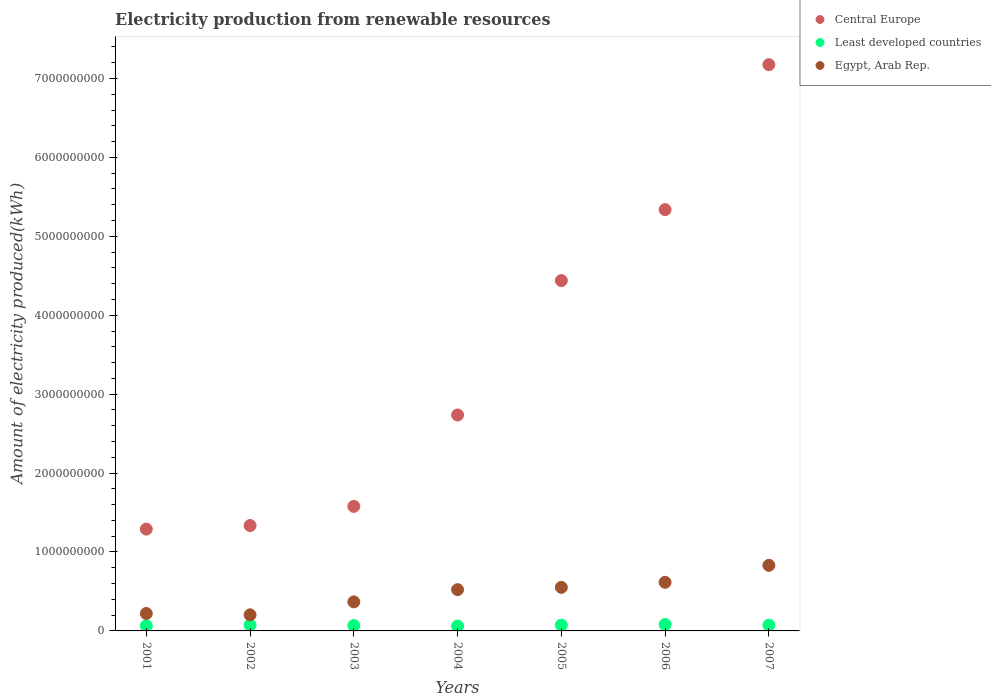Is the number of dotlines equal to the number of legend labels?
Keep it short and to the point. Yes. What is the amount of electricity produced in Egypt, Arab Rep. in 2002?
Offer a very short reply. 2.04e+08. Across all years, what is the maximum amount of electricity produced in Egypt, Arab Rep.?
Ensure brevity in your answer.  8.31e+08. Across all years, what is the minimum amount of electricity produced in Egypt, Arab Rep.?
Provide a succinct answer. 2.04e+08. In which year was the amount of electricity produced in Central Europe maximum?
Your answer should be compact. 2007. In which year was the amount of electricity produced in Central Europe minimum?
Offer a very short reply. 2001. What is the total amount of electricity produced in Least developed countries in the graph?
Keep it short and to the point. 4.96e+08. What is the difference between the amount of electricity produced in Egypt, Arab Rep. in 2001 and that in 2007?
Keep it short and to the point. -6.10e+08. What is the difference between the amount of electricity produced in Central Europe in 2006 and the amount of electricity produced in Egypt, Arab Rep. in 2002?
Your answer should be compact. 5.13e+09. What is the average amount of electricity produced in Least developed countries per year?
Provide a succinct answer. 7.09e+07. In the year 2004, what is the difference between the amount of electricity produced in Egypt, Arab Rep. and amount of electricity produced in Least developed countries?
Provide a succinct answer. 4.61e+08. What is the ratio of the amount of electricity produced in Central Europe in 2004 to that in 2005?
Provide a short and direct response. 0.62. Is the difference between the amount of electricity produced in Egypt, Arab Rep. in 2003 and 2005 greater than the difference between the amount of electricity produced in Least developed countries in 2003 and 2005?
Provide a short and direct response. No. What is the difference between the highest and the second highest amount of electricity produced in Egypt, Arab Rep.?
Give a very brief answer. 2.15e+08. What is the difference between the highest and the lowest amount of electricity produced in Central Europe?
Your answer should be compact. 5.88e+09. In how many years, is the amount of electricity produced in Egypt, Arab Rep. greater than the average amount of electricity produced in Egypt, Arab Rep. taken over all years?
Provide a succinct answer. 4. Does the amount of electricity produced in Central Europe monotonically increase over the years?
Provide a short and direct response. Yes. How many dotlines are there?
Offer a very short reply. 3. How many years are there in the graph?
Offer a very short reply. 7. What is the difference between two consecutive major ticks on the Y-axis?
Offer a very short reply. 1.00e+09. Does the graph contain any zero values?
Make the answer very short. No. How many legend labels are there?
Your answer should be very brief. 3. How are the legend labels stacked?
Offer a terse response. Vertical. What is the title of the graph?
Your answer should be very brief. Electricity production from renewable resources. Does "Saudi Arabia" appear as one of the legend labels in the graph?
Offer a terse response. No. What is the label or title of the Y-axis?
Offer a very short reply. Amount of electricity produced(kWh). What is the Amount of electricity produced(kWh) in Central Europe in 2001?
Your answer should be compact. 1.29e+09. What is the Amount of electricity produced(kWh) in Least developed countries in 2001?
Provide a short and direct response. 6.60e+07. What is the Amount of electricity produced(kWh) of Egypt, Arab Rep. in 2001?
Give a very brief answer. 2.21e+08. What is the Amount of electricity produced(kWh) of Central Europe in 2002?
Offer a terse response. 1.34e+09. What is the Amount of electricity produced(kWh) in Least developed countries in 2002?
Offer a terse response. 7.30e+07. What is the Amount of electricity produced(kWh) of Egypt, Arab Rep. in 2002?
Offer a very short reply. 2.04e+08. What is the Amount of electricity produced(kWh) in Central Europe in 2003?
Make the answer very short. 1.58e+09. What is the Amount of electricity produced(kWh) of Least developed countries in 2003?
Ensure brevity in your answer.  6.80e+07. What is the Amount of electricity produced(kWh) in Egypt, Arab Rep. in 2003?
Offer a very short reply. 3.68e+08. What is the Amount of electricity produced(kWh) in Central Europe in 2004?
Provide a short and direct response. 2.74e+09. What is the Amount of electricity produced(kWh) of Least developed countries in 2004?
Give a very brief answer. 6.20e+07. What is the Amount of electricity produced(kWh) of Egypt, Arab Rep. in 2004?
Keep it short and to the point. 5.23e+08. What is the Amount of electricity produced(kWh) in Central Europe in 2005?
Offer a terse response. 4.44e+09. What is the Amount of electricity produced(kWh) in Least developed countries in 2005?
Your answer should be compact. 7.30e+07. What is the Amount of electricity produced(kWh) of Egypt, Arab Rep. in 2005?
Offer a terse response. 5.52e+08. What is the Amount of electricity produced(kWh) in Central Europe in 2006?
Keep it short and to the point. 5.34e+09. What is the Amount of electricity produced(kWh) in Least developed countries in 2006?
Provide a short and direct response. 8.10e+07. What is the Amount of electricity produced(kWh) in Egypt, Arab Rep. in 2006?
Offer a very short reply. 6.16e+08. What is the Amount of electricity produced(kWh) in Central Europe in 2007?
Provide a succinct answer. 7.18e+09. What is the Amount of electricity produced(kWh) in Least developed countries in 2007?
Your answer should be compact. 7.30e+07. What is the Amount of electricity produced(kWh) of Egypt, Arab Rep. in 2007?
Provide a short and direct response. 8.31e+08. Across all years, what is the maximum Amount of electricity produced(kWh) of Central Europe?
Provide a short and direct response. 7.18e+09. Across all years, what is the maximum Amount of electricity produced(kWh) of Least developed countries?
Provide a succinct answer. 8.10e+07. Across all years, what is the maximum Amount of electricity produced(kWh) of Egypt, Arab Rep.?
Your answer should be compact. 8.31e+08. Across all years, what is the minimum Amount of electricity produced(kWh) in Central Europe?
Offer a very short reply. 1.29e+09. Across all years, what is the minimum Amount of electricity produced(kWh) in Least developed countries?
Provide a short and direct response. 6.20e+07. Across all years, what is the minimum Amount of electricity produced(kWh) in Egypt, Arab Rep.?
Provide a short and direct response. 2.04e+08. What is the total Amount of electricity produced(kWh) in Central Europe in the graph?
Your answer should be very brief. 2.39e+1. What is the total Amount of electricity produced(kWh) of Least developed countries in the graph?
Give a very brief answer. 4.96e+08. What is the total Amount of electricity produced(kWh) of Egypt, Arab Rep. in the graph?
Provide a short and direct response. 3.32e+09. What is the difference between the Amount of electricity produced(kWh) in Central Europe in 2001 and that in 2002?
Make the answer very short. -4.50e+07. What is the difference between the Amount of electricity produced(kWh) of Least developed countries in 2001 and that in 2002?
Provide a short and direct response. -7.00e+06. What is the difference between the Amount of electricity produced(kWh) in Egypt, Arab Rep. in 2001 and that in 2002?
Your response must be concise. 1.70e+07. What is the difference between the Amount of electricity produced(kWh) of Central Europe in 2001 and that in 2003?
Offer a very short reply. -2.88e+08. What is the difference between the Amount of electricity produced(kWh) in Egypt, Arab Rep. in 2001 and that in 2003?
Provide a succinct answer. -1.47e+08. What is the difference between the Amount of electricity produced(kWh) of Central Europe in 2001 and that in 2004?
Make the answer very short. -1.45e+09. What is the difference between the Amount of electricity produced(kWh) of Egypt, Arab Rep. in 2001 and that in 2004?
Provide a short and direct response. -3.02e+08. What is the difference between the Amount of electricity produced(kWh) of Central Europe in 2001 and that in 2005?
Your answer should be compact. -3.15e+09. What is the difference between the Amount of electricity produced(kWh) of Least developed countries in 2001 and that in 2005?
Your answer should be compact. -7.00e+06. What is the difference between the Amount of electricity produced(kWh) in Egypt, Arab Rep. in 2001 and that in 2005?
Make the answer very short. -3.31e+08. What is the difference between the Amount of electricity produced(kWh) of Central Europe in 2001 and that in 2006?
Provide a succinct answer. -4.05e+09. What is the difference between the Amount of electricity produced(kWh) of Least developed countries in 2001 and that in 2006?
Provide a succinct answer. -1.50e+07. What is the difference between the Amount of electricity produced(kWh) of Egypt, Arab Rep. in 2001 and that in 2006?
Your answer should be very brief. -3.95e+08. What is the difference between the Amount of electricity produced(kWh) of Central Europe in 2001 and that in 2007?
Your answer should be compact. -5.88e+09. What is the difference between the Amount of electricity produced(kWh) in Least developed countries in 2001 and that in 2007?
Make the answer very short. -7.00e+06. What is the difference between the Amount of electricity produced(kWh) of Egypt, Arab Rep. in 2001 and that in 2007?
Provide a short and direct response. -6.10e+08. What is the difference between the Amount of electricity produced(kWh) in Central Europe in 2002 and that in 2003?
Keep it short and to the point. -2.43e+08. What is the difference between the Amount of electricity produced(kWh) of Least developed countries in 2002 and that in 2003?
Your response must be concise. 5.00e+06. What is the difference between the Amount of electricity produced(kWh) in Egypt, Arab Rep. in 2002 and that in 2003?
Ensure brevity in your answer.  -1.64e+08. What is the difference between the Amount of electricity produced(kWh) of Central Europe in 2002 and that in 2004?
Offer a terse response. -1.40e+09. What is the difference between the Amount of electricity produced(kWh) in Least developed countries in 2002 and that in 2004?
Offer a very short reply. 1.10e+07. What is the difference between the Amount of electricity produced(kWh) in Egypt, Arab Rep. in 2002 and that in 2004?
Make the answer very short. -3.19e+08. What is the difference between the Amount of electricity produced(kWh) in Central Europe in 2002 and that in 2005?
Your response must be concise. -3.10e+09. What is the difference between the Amount of electricity produced(kWh) of Least developed countries in 2002 and that in 2005?
Your answer should be compact. 0. What is the difference between the Amount of electricity produced(kWh) of Egypt, Arab Rep. in 2002 and that in 2005?
Give a very brief answer. -3.48e+08. What is the difference between the Amount of electricity produced(kWh) of Central Europe in 2002 and that in 2006?
Make the answer very short. -4.00e+09. What is the difference between the Amount of electricity produced(kWh) of Least developed countries in 2002 and that in 2006?
Offer a terse response. -8.00e+06. What is the difference between the Amount of electricity produced(kWh) of Egypt, Arab Rep. in 2002 and that in 2006?
Provide a short and direct response. -4.12e+08. What is the difference between the Amount of electricity produced(kWh) of Central Europe in 2002 and that in 2007?
Give a very brief answer. -5.84e+09. What is the difference between the Amount of electricity produced(kWh) in Egypt, Arab Rep. in 2002 and that in 2007?
Your answer should be very brief. -6.27e+08. What is the difference between the Amount of electricity produced(kWh) of Central Europe in 2003 and that in 2004?
Your answer should be compact. -1.16e+09. What is the difference between the Amount of electricity produced(kWh) of Egypt, Arab Rep. in 2003 and that in 2004?
Keep it short and to the point. -1.55e+08. What is the difference between the Amount of electricity produced(kWh) in Central Europe in 2003 and that in 2005?
Keep it short and to the point. -2.86e+09. What is the difference between the Amount of electricity produced(kWh) in Least developed countries in 2003 and that in 2005?
Offer a terse response. -5.00e+06. What is the difference between the Amount of electricity produced(kWh) in Egypt, Arab Rep. in 2003 and that in 2005?
Ensure brevity in your answer.  -1.84e+08. What is the difference between the Amount of electricity produced(kWh) in Central Europe in 2003 and that in 2006?
Give a very brief answer. -3.76e+09. What is the difference between the Amount of electricity produced(kWh) of Least developed countries in 2003 and that in 2006?
Your response must be concise. -1.30e+07. What is the difference between the Amount of electricity produced(kWh) of Egypt, Arab Rep. in 2003 and that in 2006?
Your answer should be compact. -2.48e+08. What is the difference between the Amount of electricity produced(kWh) of Central Europe in 2003 and that in 2007?
Keep it short and to the point. -5.60e+09. What is the difference between the Amount of electricity produced(kWh) of Least developed countries in 2003 and that in 2007?
Ensure brevity in your answer.  -5.00e+06. What is the difference between the Amount of electricity produced(kWh) of Egypt, Arab Rep. in 2003 and that in 2007?
Ensure brevity in your answer.  -4.63e+08. What is the difference between the Amount of electricity produced(kWh) in Central Europe in 2004 and that in 2005?
Your answer should be compact. -1.70e+09. What is the difference between the Amount of electricity produced(kWh) of Least developed countries in 2004 and that in 2005?
Your response must be concise. -1.10e+07. What is the difference between the Amount of electricity produced(kWh) in Egypt, Arab Rep. in 2004 and that in 2005?
Your answer should be very brief. -2.90e+07. What is the difference between the Amount of electricity produced(kWh) of Central Europe in 2004 and that in 2006?
Ensure brevity in your answer.  -2.60e+09. What is the difference between the Amount of electricity produced(kWh) of Least developed countries in 2004 and that in 2006?
Give a very brief answer. -1.90e+07. What is the difference between the Amount of electricity produced(kWh) in Egypt, Arab Rep. in 2004 and that in 2006?
Your answer should be very brief. -9.30e+07. What is the difference between the Amount of electricity produced(kWh) of Central Europe in 2004 and that in 2007?
Your answer should be compact. -4.44e+09. What is the difference between the Amount of electricity produced(kWh) of Least developed countries in 2004 and that in 2007?
Make the answer very short. -1.10e+07. What is the difference between the Amount of electricity produced(kWh) of Egypt, Arab Rep. in 2004 and that in 2007?
Keep it short and to the point. -3.08e+08. What is the difference between the Amount of electricity produced(kWh) in Central Europe in 2005 and that in 2006?
Your response must be concise. -8.99e+08. What is the difference between the Amount of electricity produced(kWh) in Least developed countries in 2005 and that in 2006?
Your answer should be compact. -8.00e+06. What is the difference between the Amount of electricity produced(kWh) in Egypt, Arab Rep. in 2005 and that in 2006?
Your answer should be very brief. -6.40e+07. What is the difference between the Amount of electricity produced(kWh) of Central Europe in 2005 and that in 2007?
Keep it short and to the point. -2.74e+09. What is the difference between the Amount of electricity produced(kWh) in Egypt, Arab Rep. in 2005 and that in 2007?
Your answer should be very brief. -2.79e+08. What is the difference between the Amount of electricity produced(kWh) in Central Europe in 2006 and that in 2007?
Keep it short and to the point. -1.84e+09. What is the difference between the Amount of electricity produced(kWh) in Least developed countries in 2006 and that in 2007?
Offer a very short reply. 8.00e+06. What is the difference between the Amount of electricity produced(kWh) of Egypt, Arab Rep. in 2006 and that in 2007?
Provide a short and direct response. -2.15e+08. What is the difference between the Amount of electricity produced(kWh) in Central Europe in 2001 and the Amount of electricity produced(kWh) in Least developed countries in 2002?
Offer a terse response. 1.22e+09. What is the difference between the Amount of electricity produced(kWh) in Central Europe in 2001 and the Amount of electricity produced(kWh) in Egypt, Arab Rep. in 2002?
Provide a succinct answer. 1.09e+09. What is the difference between the Amount of electricity produced(kWh) of Least developed countries in 2001 and the Amount of electricity produced(kWh) of Egypt, Arab Rep. in 2002?
Offer a terse response. -1.38e+08. What is the difference between the Amount of electricity produced(kWh) of Central Europe in 2001 and the Amount of electricity produced(kWh) of Least developed countries in 2003?
Keep it short and to the point. 1.22e+09. What is the difference between the Amount of electricity produced(kWh) of Central Europe in 2001 and the Amount of electricity produced(kWh) of Egypt, Arab Rep. in 2003?
Your answer should be compact. 9.22e+08. What is the difference between the Amount of electricity produced(kWh) of Least developed countries in 2001 and the Amount of electricity produced(kWh) of Egypt, Arab Rep. in 2003?
Provide a short and direct response. -3.02e+08. What is the difference between the Amount of electricity produced(kWh) in Central Europe in 2001 and the Amount of electricity produced(kWh) in Least developed countries in 2004?
Give a very brief answer. 1.23e+09. What is the difference between the Amount of electricity produced(kWh) in Central Europe in 2001 and the Amount of electricity produced(kWh) in Egypt, Arab Rep. in 2004?
Make the answer very short. 7.67e+08. What is the difference between the Amount of electricity produced(kWh) in Least developed countries in 2001 and the Amount of electricity produced(kWh) in Egypt, Arab Rep. in 2004?
Your response must be concise. -4.57e+08. What is the difference between the Amount of electricity produced(kWh) of Central Europe in 2001 and the Amount of electricity produced(kWh) of Least developed countries in 2005?
Provide a short and direct response. 1.22e+09. What is the difference between the Amount of electricity produced(kWh) of Central Europe in 2001 and the Amount of electricity produced(kWh) of Egypt, Arab Rep. in 2005?
Ensure brevity in your answer.  7.38e+08. What is the difference between the Amount of electricity produced(kWh) in Least developed countries in 2001 and the Amount of electricity produced(kWh) in Egypt, Arab Rep. in 2005?
Your answer should be compact. -4.86e+08. What is the difference between the Amount of electricity produced(kWh) of Central Europe in 2001 and the Amount of electricity produced(kWh) of Least developed countries in 2006?
Ensure brevity in your answer.  1.21e+09. What is the difference between the Amount of electricity produced(kWh) of Central Europe in 2001 and the Amount of electricity produced(kWh) of Egypt, Arab Rep. in 2006?
Offer a very short reply. 6.74e+08. What is the difference between the Amount of electricity produced(kWh) of Least developed countries in 2001 and the Amount of electricity produced(kWh) of Egypt, Arab Rep. in 2006?
Offer a very short reply. -5.50e+08. What is the difference between the Amount of electricity produced(kWh) of Central Europe in 2001 and the Amount of electricity produced(kWh) of Least developed countries in 2007?
Provide a short and direct response. 1.22e+09. What is the difference between the Amount of electricity produced(kWh) of Central Europe in 2001 and the Amount of electricity produced(kWh) of Egypt, Arab Rep. in 2007?
Your answer should be very brief. 4.59e+08. What is the difference between the Amount of electricity produced(kWh) in Least developed countries in 2001 and the Amount of electricity produced(kWh) in Egypt, Arab Rep. in 2007?
Your answer should be very brief. -7.65e+08. What is the difference between the Amount of electricity produced(kWh) in Central Europe in 2002 and the Amount of electricity produced(kWh) in Least developed countries in 2003?
Your answer should be very brief. 1.27e+09. What is the difference between the Amount of electricity produced(kWh) in Central Europe in 2002 and the Amount of electricity produced(kWh) in Egypt, Arab Rep. in 2003?
Your answer should be compact. 9.67e+08. What is the difference between the Amount of electricity produced(kWh) in Least developed countries in 2002 and the Amount of electricity produced(kWh) in Egypt, Arab Rep. in 2003?
Your response must be concise. -2.95e+08. What is the difference between the Amount of electricity produced(kWh) in Central Europe in 2002 and the Amount of electricity produced(kWh) in Least developed countries in 2004?
Offer a very short reply. 1.27e+09. What is the difference between the Amount of electricity produced(kWh) in Central Europe in 2002 and the Amount of electricity produced(kWh) in Egypt, Arab Rep. in 2004?
Offer a terse response. 8.12e+08. What is the difference between the Amount of electricity produced(kWh) of Least developed countries in 2002 and the Amount of electricity produced(kWh) of Egypt, Arab Rep. in 2004?
Make the answer very short. -4.50e+08. What is the difference between the Amount of electricity produced(kWh) of Central Europe in 2002 and the Amount of electricity produced(kWh) of Least developed countries in 2005?
Keep it short and to the point. 1.26e+09. What is the difference between the Amount of electricity produced(kWh) in Central Europe in 2002 and the Amount of electricity produced(kWh) in Egypt, Arab Rep. in 2005?
Give a very brief answer. 7.83e+08. What is the difference between the Amount of electricity produced(kWh) of Least developed countries in 2002 and the Amount of electricity produced(kWh) of Egypt, Arab Rep. in 2005?
Your response must be concise. -4.79e+08. What is the difference between the Amount of electricity produced(kWh) in Central Europe in 2002 and the Amount of electricity produced(kWh) in Least developed countries in 2006?
Your answer should be very brief. 1.25e+09. What is the difference between the Amount of electricity produced(kWh) of Central Europe in 2002 and the Amount of electricity produced(kWh) of Egypt, Arab Rep. in 2006?
Offer a very short reply. 7.19e+08. What is the difference between the Amount of electricity produced(kWh) of Least developed countries in 2002 and the Amount of electricity produced(kWh) of Egypt, Arab Rep. in 2006?
Give a very brief answer. -5.43e+08. What is the difference between the Amount of electricity produced(kWh) in Central Europe in 2002 and the Amount of electricity produced(kWh) in Least developed countries in 2007?
Offer a terse response. 1.26e+09. What is the difference between the Amount of electricity produced(kWh) in Central Europe in 2002 and the Amount of electricity produced(kWh) in Egypt, Arab Rep. in 2007?
Give a very brief answer. 5.04e+08. What is the difference between the Amount of electricity produced(kWh) of Least developed countries in 2002 and the Amount of electricity produced(kWh) of Egypt, Arab Rep. in 2007?
Your response must be concise. -7.58e+08. What is the difference between the Amount of electricity produced(kWh) of Central Europe in 2003 and the Amount of electricity produced(kWh) of Least developed countries in 2004?
Offer a terse response. 1.52e+09. What is the difference between the Amount of electricity produced(kWh) in Central Europe in 2003 and the Amount of electricity produced(kWh) in Egypt, Arab Rep. in 2004?
Give a very brief answer. 1.06e+09. What is the difference between the Amount of electricity produced(kWh) in Least developed countries in 2003 and the Amount of electricity produced(kWh) in Egypt, Arab Rep. in 2004?
Offer a very short reply. -4.55e+08. What is the difference between the Amount of electricity produced(kWh) in Central Europe in 2003 and the Amount of electricity produced(kWh) in Least developed countries in 2005?
Offer a terse response. 1.50e+09. What is the difference between the Amount of electricity produced(kWh) of Central Europe in 2003 and the Amount of electricity produced(kWh) of Egypt, Arab Rep. in 2005?
Make the answer very short. 1.03e+09. What is the difference between the Amount of electricity produced(kWh) of Least developed countries in 2003 and the Amount of electricity produced(kWh) of Egypt, Arab Rep. in 2005?
Provide a short and direct response. -4.84e+08. What is the difference between the Amount of electricity produced(kWh) of Central Europe in 2003 and the Amount of electricity produced(kWh) of Least developed countries in 2006?
Give a very brief answer. 1.50e+09. What is the difference between the Amount of electricity produced(kWh) in Central Europe in 2003 and the Amount of electricity produced(kWh) in Egypt, Arab Rep. in 2006?
Your answer should be very brief. 9.62e+08. What is the difference between the Amount of electricity produced(kWh) of Least developed countries in 2003 and the Amount of electricity produced(kWh) of Egypt, Arab Rep. in 2006?
Provide a succinct answer. -5.48e+08. What is the difference between the Amount of electricity produced(kWh) of Central Europe in 2003 and the Amount of electricity produced(kWh) of Least developed countries in 2007?
Provide a succinct answer. 1.50e+09. What is the difference between the Amount of electricity produced(kWh) of Central Europe in 2003 and the Amount of electricity produced(kWh) of Egypt, Arab Rep. in 2007?
Provide a short and direct response. 7.47e+08. What is the difference between the Amount of electricity produced(kWh) of Least developed countries in 2003 and the Amount of electricity produced(kWh) of Egypt, Arab Rep. in 2007?
Your response must be concise. -7.63e+08. What is the difference between the Amount of electricity produced(kWh) of Central Europe in 2004 and the Amount of electricity produced(kWh) of Least developed countries in 2005?
Give a very brief answer. 2.66e+09. What is the difference between the Amount of electricity produced(kWh) in Central Europe in 2004 and the Amount of electricity produced(kWh) in Egypt, Arab Rep. in 2005?
Your response must be concise. 2.18e+09. What is the difference between the Amount of electricity produced(kWh) of Least developed countries in 2004 and the Amount of electricity produced(kWh) of Egypt, Arab Rep. in 2005?
Ensure brevity in your answer.  -4.90e+08. What is the difference between the Amount of electricity produced(kWh) in Central Europe in 2004 and the Amount of electricity produced(kWh) in Least developed countries in 2006?
Give a very brief answer. 2.66e+09. What is the difference between the Amount of electricity produced(kWh) of Central Europe in 2004 and the Amount of electricity produced(kWh) of Egypt, Arab Rep. in 2006?
Your answer should be compact. 2.12e+09. What is the difference between the Amount of electricity produced(kWh) of Least developed countries in 2004 and the Amount of electricity produced(kWh) of Egypt, Arab Rep. in 2006?
Keep it short and to the point. -5.54e+08. What is the difference between the Amount of electricity produced(kWh) in Central Europe in 2004 and the Amount of electricity produced(kWh) in Least developed countries in 2007?
Make the answer very short. 2.66e+09. What is the difference between the Amount of electricity produced(kWh) in Central Europe in 2004 and the Amount of electricity produced(kWh) in Egypt, Arab Rep. in 2007?
Give a very brief answer. 1.90e+09. What is the difference between the Amount of electricity produced(kWh) in Least developed countries in 2004 and the Amount of electricity produced(kWh) in Egypt, Arab Rep. in 2007?
Your answer should be very brief. -7.69e+08. What is the difference between the Amount of electricity produced(kWh) of Central Europe in 2005 and the Amount of electricity produced(kWh) of Least developed countries in 2006?
Your answer should be compact. 4.36e+09. What is the difference between the Amount of electricity produced(kWh) in Central Europe in 2005 and the Amount of electricity produced(kWh) in Egypt, Arab Rep. in 2006?
Provide a short and direct response. 3.82e+09. What is the difference between the Amount of electricity produced(kWh) in Least developed countries in 2005 and the Amount of electricity produced(kWh) in Egypt, Arab Rep. in 2006?
Offer a very short reply. -5.43e+08. What is the difference between the Amount of electricity produced(kWh) of Central Europe in 2005 and the Amount of electricity produced(kWh) of Least developed countries in 2007?
Ensure brevity in your answer.  4.37e+09. What is the difference between the Amount of electricity produced(kWh) of Central Europe in 2005 and the Amount of electricity produced(kWh) of Egypt, Arab Rep. in 2007?
Keep it short and to the point. 3.61e+09. What is the difference between the Amount of electricity produced(kWh) in Least developed countries in 2005 and the Amount of electricity produced(kWh) in Egypt, Arab Rep. in 2007?
Your answer should be compact. -7.58e+08. What is the difference between the Amount of electricity produced(kWh) of Central Europe in 2006 and the Amount of electricity produced(kWh) of Least developed countries in 2007?
Your response must be concise. 5.26e+09. What is the difference between the Amount of electricity produced(kWh) in Central Europe in 2006 and the Amount of electricity produced(kWh) in Egypt, Arab Rep. in 2007?
Provide a short and direct response. 4.51e+09. What is the difference between the Amount of electricity produced(kWh) in Least developed countries in 2006 and the Amount of electricity produced(kWh) in Egypt, Arab Rep. in 2007?
Offer a terse response. -7.50e+08. What is the average Amount of electricity produced(kWh) in Central Europe per year?
Provide a succinct answer. 3.41e+09. What is the average Amount of electricity produced(kWh) of Least developed countries per year?
Provide a succinct answer. 7.09e+07. What is the average Amount of electricity produced(kWh) of Egypt, Arab Rep. per year?
Give a very brief answer. 4.74e+08. In the year 2001, what is the difference between the Amount of electricity produced(kWh) in Central Europe and Amount of electricity produced(kWh) in Least developed countries?
Offer a terse response. 1.22e+09. In the year 2001, what is the difference between the Amount of electricity produced(kWh) in Central Europe and Amount of electricity produced(kWh) in Egypt, Arab Rep.?
Provide a short and direct response. 1.07e+09. In the year 2001, what is the difference between the Amount of electricity produced(kWh) of Least developed countries and Amount of electricity produced(kWh) of Egypt, Arab Rep.?
Give a very brief answer. -1.55e+08. In the year 2002, what is the difference between the Amount of electricity produced(kWh) in Central Europe and Amount of electricity produced(kWh) in Least developed countries?
Give a very brief answer. 1.26e+09. In the year 2002, what is the difference between the Amount of electricity produced(kWh) of Central Europe and Amount of electricity produced(kWh) of Egypt, Arab Rep.?
Provide a short and direct response. 1.13e+09. In the year 2002, what is the difference between the Amount of electricity produced(kWh) of Least developed countries and Amount of electricity produced(kWh) of Egypt, Arab Rep.?
Offer a terse response. -1.31e+08. In the year 2003, what is the difference between the Amount of electricity produced(kWh) in Central Europe and Amount of electricity produced(kWh) in Least developed countries?
Offer a terse response. 1.51e+09. In the year 2003, what is the difference between the Amount of electricity produced(kWh) in Central Europe and Amount of electricity produced(kWh) in Egypt, Arab Rep.?
Keep it short and to the point. 1.21e+09. In the year 2003, what is the difference between the Amount of electricity produced(kWh) in Least developed countries and Amount of electricity produced(kWh) in Egypt, Arab Rep.?
Provide a succinct answer. -3.00e+08. In the year 2004, what is the difference between the Amount of electricity produced(kWh) of Central Europe and Amount of electricity produced(kWh) of Least developed countries?
Provide a short and direct response. 2.67e+09. In the year 2004, what is the difference between the Amount of electricity produced(kWh) of Central Europe and Amount of electricity produced(kWh) of Egypt, Arab Rep.?
Provide a short and direct response. 2.21e+09. In the year 2004, what is the difference between the Amount of electricity produced(kWh) of Least developed countries and Amount of electricity produced(kWh) of Egypt, Arab Rep.?
Provide a succinct answer. -4.61e+08. In the year 2005, what is the difference between the Amount of electricity produced(kWh) of Central Europe and Amount of electricity produced(kWh) of Least developed countries?
Give a very brief answer. 4.37e+09. In the year 2005, what is the difference between the Amount of electricity produced(kWh) of Central Europe and Amount of electricity produced(kWh) of Egypt, Arab Rep.?
Offer a very short reply. 3.89e+09. In the year 2005, what is the difference between the Amount of electricity produced(kWh) in Least developed countries and Amount of electricity produced(kWh) in Egypt, Arab Rep.?
Offer a terse response. -4.79e+08. In the year 2006, what is the difference between the Amount of electricity produced(kWh) in Central Europe and Amount of electricity produced(kWh) in Least developed countries?
Your answer should be very brief. 5.26e+09. In the year 2006, what is the difference between the Amount of electricity produced(kWh) in Central Europe and Amount of electricity produced(kWh) in Egypt, Arab Rep.?
Your answer should be compact. 4.72e+09. In the year 2006, what is the difference between the Amount of electricity produced(kWh) in Least developed countries and Amount of electricity produced(kWh) in Egypt, Arab Rep.?
Make the answer very short. -5.35e+08. In the year 2007, what is the difference between the Amount of electricity produced(kWh) in Central Europe and Amount of electricity produced(kWh) in Least developed countries?
Make the answer very short. 7.10e+09. In the year 2007, what is the difference between the Amount of electricity produced(kWh) in Central Europe and Amount of electricity produced(kWh) in Egypt, Arab Rep.?
Keep it short and to the point. 6.34e+09. In the year 2007, what is the difference between the Amount of electricity produced(kWh) of Least developed countries and Amount of electricity produced(kWh) of Egypt, Arab Rep.?
Provide a short and direct response. -7.58e+08. What is the ratio of the Amount of electricity produced(kWh) of Central Europe in 2001 to that in 2002?
Offer a very short reply. 0.97. What is the ratio of the Amount of electricity produced(kWh) in Least developed countries in 2001 to that in 2002?
Give a very brief answer. 0.9. What is the ratio of the Amount of electricity produced(kWh) in Egypt, Arab Rep. in 2001 to that in 2002?
Give a very brief answer. 1.08. What is the ratio of the Amount of electricity produced(kWh) in Central Europe in 2001 to that in 2003?
Give a very brief answer. 0.82. What is the ratio of the Amount of electricity produced(kWh) in Least developed countries in 2001 to that in 2003?
Provide a succinct answer. 0.97. What is the ratio of the Amount of electricity produced(kWh) of Egypt, Arab Rep. in 2001 to that in 2003?
Offer a very short reply. 0.6. What is the ratio of the Amount of electricity produced(kWh) of Central Europe in 2001 to that in 2004?
Make the answer very short. 0.47. What is the ratio of the Amount of electricity produced(kWh) in Least developed countries in 2001 to that in 2004?
Offer a terse response. 1.06. What is the ratio of the Amount of electricity produced(kWh) of Egypt, Arab Rep. in 2001 to that in 2004?
Ensure brevity in your answer.  0.42. What is the ratio of the Amount of electricity produced(kWh) in Central Europe in 2001 to that in 2005?
Offer a terse response. 0.29. What is the ratio of the Amount of electricity produced(kWh) in Least developed countries in 2001 to that in 2005?
Make the answer very short. 0.9. What is the ratio of the Amount of electricity produced(kWh) in Egypt, Arab Rep. in 2001 to that in 2005?
Your answer should be very brief. 0.4. What is the ratio of the Amount of electricity produced(kWh) in Central Europe in 2001 to that in 2006?
Make the answer very short. 0.24. What is the ratio of the Amount of electricity produced(kWh) in Least developed countries in 2001 to that in 2006?
Keep it short and to the point. 0.81. What is the ratio of the Amount of electricity produced(kWh) of Egypt, Arab Rep. in 2001 to that in 2006?
Provide a succinct answer. 0.36. What is the ratio of the Amount of electricity produced(kWh) of Central Europe in 2001 to that in 2007?
Provide a short and direct response. 0.18. What is the ratio of the Amount of electricity produced(kWh) of Least developed countries in 2001 to that in 2007?
Offer a terse response. 0.9. What is the ratio of the Amount of electricity produced(kWh) in Egypt, Arab Rep. in 2001 to that in 2007?
Offer a terse response. 0.27. What is the ratio of the Amount of electricity produced(kWh) of Central Europe in 2002 to that in 2003?
Provide a succinct answer. 0.85. What is the ratio of the Amount of electricity produced(kWh) of Least developed countries in 2002 to that in 2003?
Give a very brief answer. 1.07. What is the ratio of the Amount of electricity produced(kWh) in Egypt, Arab Rep. in 2002 to that in 2003?
Make the answer very short. 0.55. What is the ratio of the Amount of electricity produced(kWh) in Central Europe in 2002 to that in 2004?
Your answer should be compact. 0.49. What is the ratio of the Amount of electricity produced(kWh) of Least developed countries in 2002 to that in 2004?
Make the answer very short. 1.18. What is the ratio of the Amount of electricity produced(kWh) in Egypt, Arab Rep. in 2002 to that in 2004?
Your answer should be very brief. 0.39. What is the ratio of the Amount of electricity produced(kWh) of Central Europe in 2002 to that in 2005?
Your answer should be compact. 0.3. What is the ratio of the Amount of electricity produced(kWh) of Least developed countries in 2002 to that in 2005?
Give a very brief answer. 1. What is the ratio of the Amount of electricity produced(kWh) of Egypt, Arab Rep. in 2002 to that in 2005?
Ensure brevity in your answer.  0.37. What is the ratio of the Amount of electricity produced(kWh) in Central Europe in 2002 to that in 2006?
Offer a terse response. 0.25. What is the ratio of the Amount of electricity produced(kWh) of Least developed countries in 2002 to that in 2006?
Give a very brief answer. 0.9. What is the ratio of the Amount of electricity produced(kWh) in Egypt, Arab Rep. in 2002 to that in 2006?
Ensure brevity in your answer.  0.33. What is the ratio of the Amount of electricity produced(kWh) of Central Europe in 2002 to that in 2007?
Provide a succinct answer. 0.19. What is the ratio of the Amount of electricity produced(kWh) in Egypt, Arab Rep. in 2002 to that in 2007?
Make the answer very short. 0.25. What is the ratio of the Amount of electricity produced(kWh) in Central Europe in 2003 to that in 2004?
Your response must be concise. 0.58. What is the ratio of the Amount of electricity produced(kWh) in Least developed countries in 2003 to that in 2004?
Offer a terse response. 1.1. What is the ratio of the Amount of electricity produced(kWh) in Egypt, Arab Rep. in 2003 to that in 2004?
Give a very brief answer. 0.7. What is the ratio of the Amount of electricity produced(kWh) of Central Europe in 2003 to that in 2005?
Offer a terse response. 0.36. What is the ratio of the Amount of electricity produced(kWh) of Least developed countries in 2003 to that in 2005?
Your answer should be compact. 0.93. What is the ratio of the Amount of electricity produced(kWh) in Egypt, Arab Rep. in 2003 to that in 2005?
Make the answer very short. 0.67. What is the ratio of the Amount of electricity produced(kWh) of Central Europe in 2003 to that in 2006?
Offer a very short reply. 0.3. What is the ratio of the Amount of electricity produced(kWh) in Least developed countries in 2003 to that in 2006?
Your response must be concise. 0.84. What is the ratio of the Amount of electricity produced(kWh) of Egypt, Arab Rep. in 2003 to that in 2006?
Ensure brevity in your answer.  0.6. What is the ratio of the Amount of electricity produced(kWh) in Central Europe in 2003 to that in 2007?
Offer a terse response. 0.22. What is the ratio of the Amount of electricity produced(kWh) in Least developed countries in 2003 to that in 2007?
Ensure brevity in your answer.  0.93. What is the ratio of the Amount of electricity produced(kWh) of Egypt, Arab Rep. in 2003 to that in 2007?
Provide a succinct answer. 0.44. What is the ratio of the Amount of electricity produced(kWh) in Central Europe in 2004 to that in 2005?
Offer a terse response. 0.62. What is the ratio of the Amount of electricity produced(kWh) of Least developed countries in 2004 to that in 2005?
Keep it short and to the point. 0.85. What is the ratio of the Amount of electricity produced(kWh) in Egypt, Arab Rep. in 2004 to that in 2005?
Ensure brevity in your answer.  0.95. What is the ratio of the Amount of electricity produced(kWh) in Central Europe in 2004 to that in 2006?
Offer a very short reply. 0.51. What is the ratio of the Amount of electricity produced(kWh) in Least developed countries in 2004 to that in 2006?
Offer a very short reply. 0.77. What is the ratio of the Amount of electricity produced(kWh) of Egypt, Arab Rep. in 2004 to that in 2006?
Ensure brevity in your answer.  0.85. What is the ratio of the Amount of electricity produced(kWh) in Central Europe in 2004 to that in 2007?
Give a very brief answer. 0.38. What is the ratio of the Amount of electricity produced(kWh) of Least developed countries in 2004 to that in 2007?
Offer a very short reply. 0.85. What is the ratio of the Amount of electricity produced(kWh) of Egypt, Arab Rep. in 2004 to that in 2007?
Offer a terse response. 0.63. What is the ratio of the Amount of electricity produced(kWh) in Central Europe in 2005 to that in 2006?
Provide a short and direct response. 0.83. What is the ratio of the Amount of electricity produced(kWh) of Least developed countries in 2005 to that in 2006?
Keep it short and to the point. 0.9. What is the ratio of the Amount of electricity produced(kWh) in Egypt, Arab Rep. in 2005 to that in 2006?
Ensure brevity in your answer.  0.9. What is the ratio of the Amount of electricity produced(kWh) in Central Europe in 2005 to that in 2007?
Offer a terse response. 0.62. What is the ratio of the Amount of electricity produced(kWh) of Least developed countries in 2005 to that in 2007?
Offer a very short reply. 1. What is the ratio of the Amount of electricity produced(kWh) of Egypt, Arab Rep. in 2005 to that in 2007?
Your answer should be very brief. 0.66. What is the ratio of the Amount of electricity produced(kWh) of Central Europe in 2006 to that in 2007?
Your response must be concise. 0.74. What is the ratio of the Amount of electricity produced(kWh) in Least developed countries in 2006 to that in 2007?
Ensure brevity in your answer.  1.11. What is the ratio of the Amount of electricity produced(kWh) in Egypt, Arab Rep. in 2006 to that in 2007?
Make the answer very short. 0.74. What is the difference between the highest and the second highest Amount of electricity produced(kWh) in Central Europe?
Give a very brief answer. 1.84e+09. What is the difference between the highest and the second highest Amount of electricity produced(kWh) of Egypt, Arab Rep.?
Your answer should be compact. 2.15e+08. What is the difference between the highest and the lowest Amount of electricity produced(kWh) in Central Europe?
Give a very brief answer. 5.88e+09. What is the difference between the highest and the lowest Amount of electricity produced(kWh) in Least developed countries?
Offer a very short reply. 1.90e+07. What is the difference between the highest and the lowest Amount of electricity produced(kWh) in Egypt, Arab Rep.?
Keep it short and to the point. 6.27e+08. 